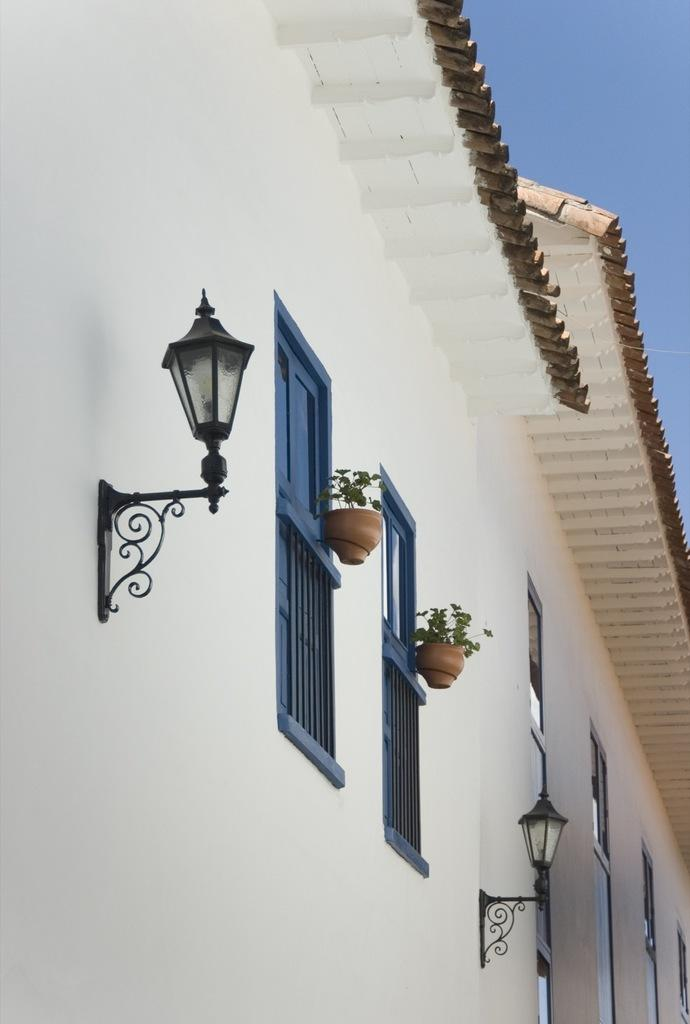What type of structure is visible in the image? There is a building with a roof in the image. What can be seen near the building? Street lamps are present in the image. Are there any plants visible in the image? Yes, there are plants in pots in the image. What features does the building have? The building has windows and railing. What is visible in the background of the image? The sky is visible in the image, and it appears to be cloudy. Can you see a rifle being used by a beast in the image? No, there is no rifle or beast present in the image. Is there a servant attending to the building in the image? No, there is no servant present in the image. 